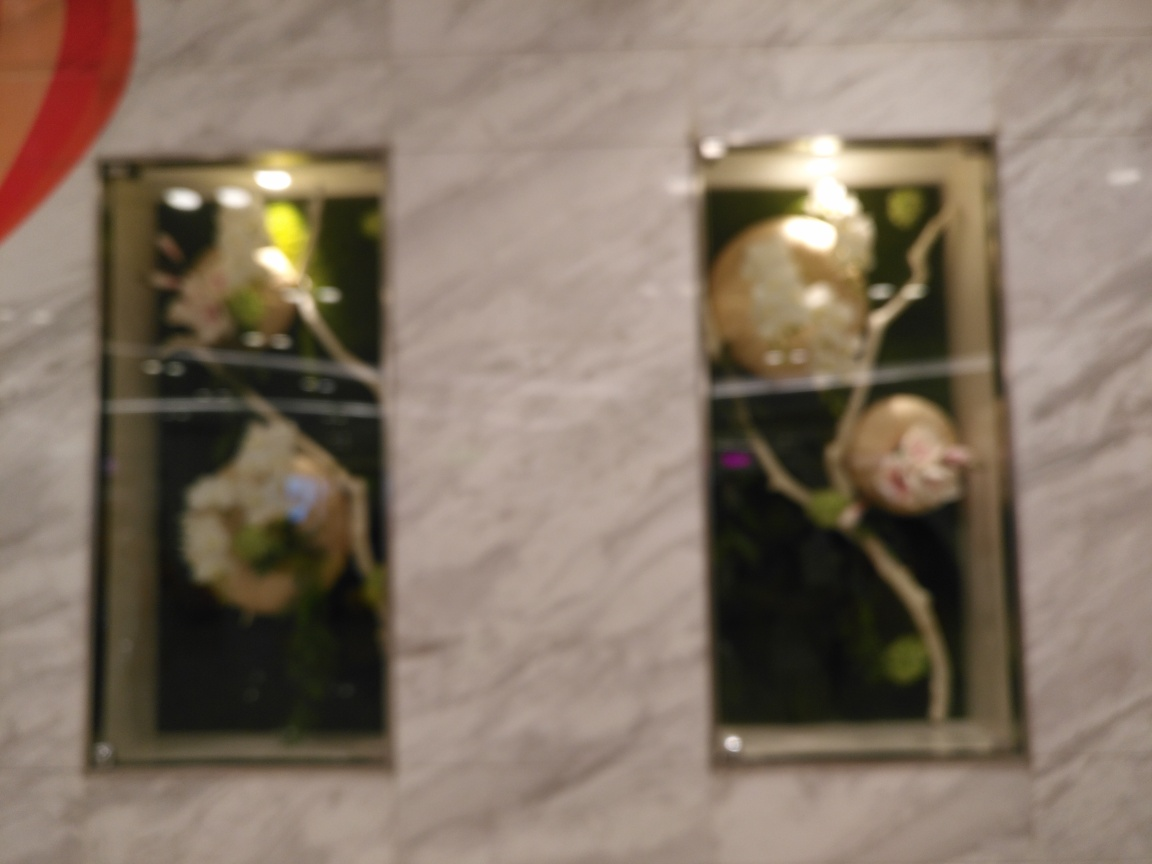Can you identify what might be causing the blurriness in this photo? The blurriness in the photo could be due to a number of factors such as camera shake during the exposure, a shallow depth of field not set properly, or an incorrect focus point. Without knowing the specific camera settings or circumstances under which the photo was taken, it's challenging to pinpoint the exact cause. 